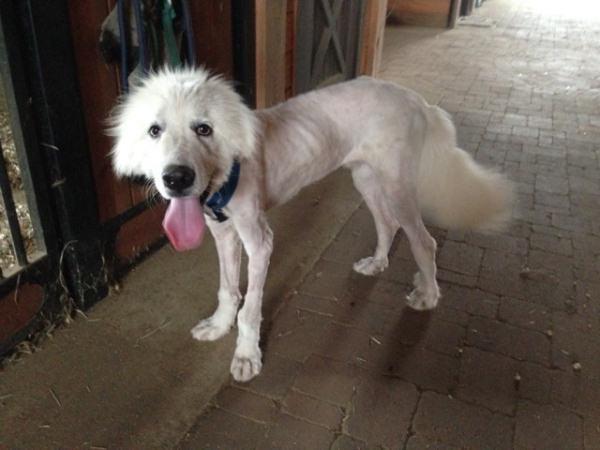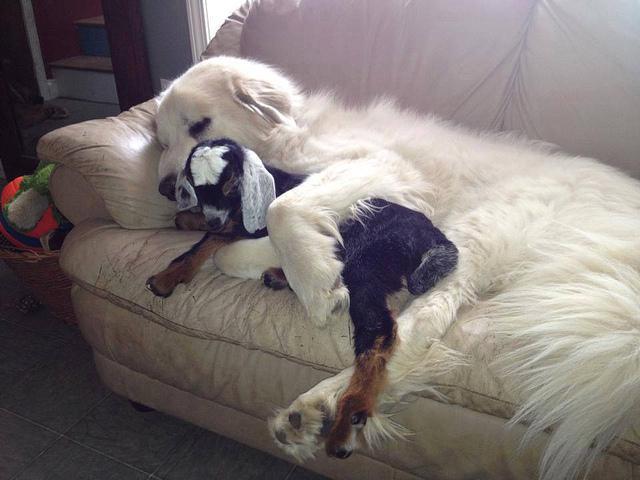The first image is the image on the left, the second image is the image on the right. Examine the images to the left and right. Is the description "A single dog is posing in a grassy area in the image on the left." accurate? Answer yes or no. No. The first image is the image on the left, the second image is the image on the right. For the images shown, is this caption "An image shows a white dog with body turned leftward, standing on all fours on a hard floor." true? Answer yes or no. Yes. 